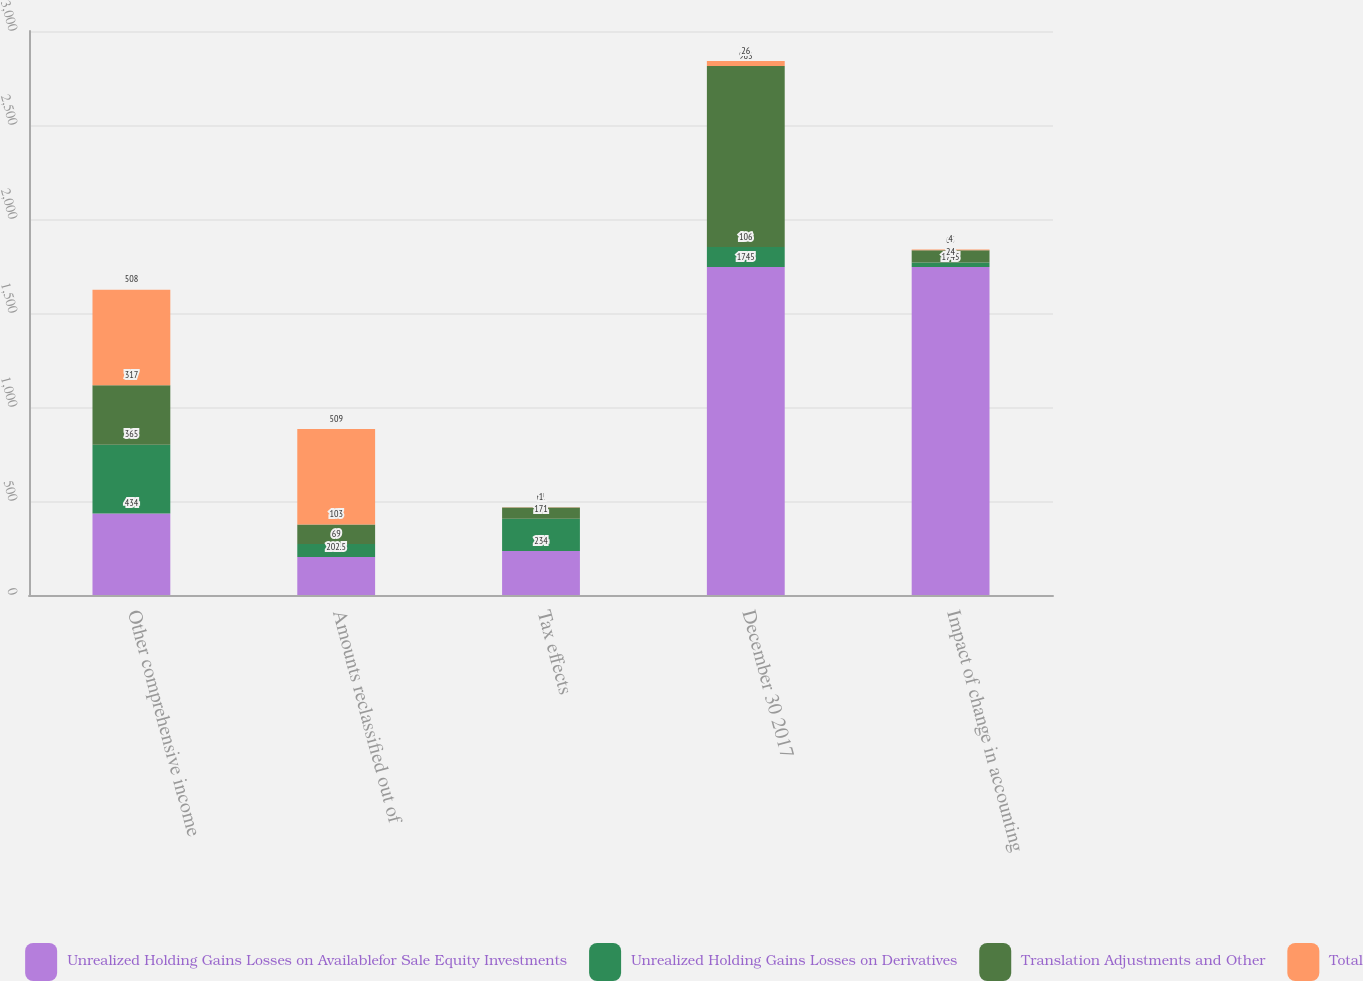Convert chart. <chart><loc_0><loc_0><loc_500><loc_500><stacked_bar_chart><ecel><fcel>Other comprehensive income<fcel>Amounts reclassified out of<fcel>Tax effects<fcel>December 30 2017<fcel>Impact of change in accounting<nl><fcel>Unrealized Holding Gains Losses on Availablefor Sale Equity Investments<fcel>434<fcel>202.5<fcel>234<fcel>1745<fcel>1745<nl><fcel>Unrealized Holding Gains Losses on Derivatives<fcel>365<fcel>69<fcel>171<fcel>106<fcel>24<nl><fcel>Translation Adjustments and Other<fcel>317<fcel>103<fcel>61<fcel>963<fcel>65<nl><fcel>Total<fcel>508<fcel>509<fcel>1<fcel>26<fcel>4<nl></chart> 